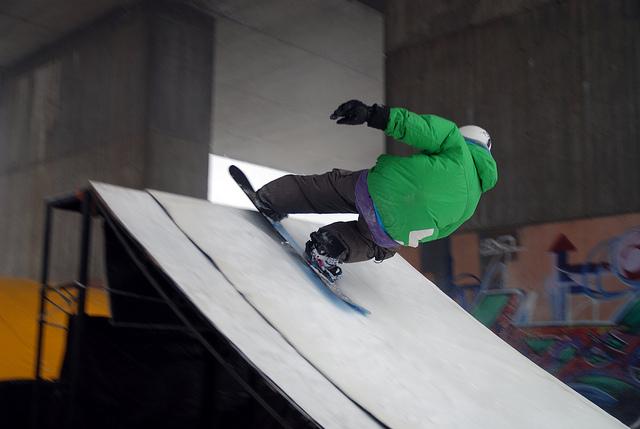What is the man doing?
Short answer required. Skateboarding. What color is his coat?
Short answer required. Green. Is the man going to fall?
Be succinct. No. Does this person have good balance?
Concise answer only. Yes. 